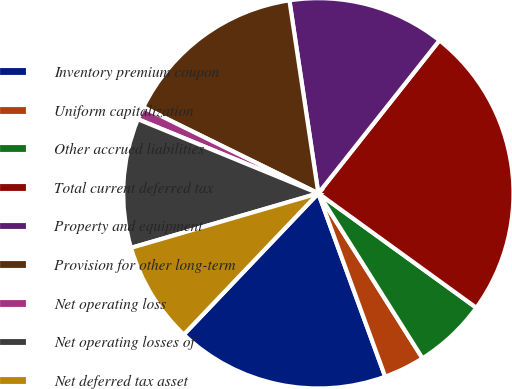Convert chart. <chart><loc_0><loc_0><loc_500><loc_500><pie_chart><fcel>Inventory premium coupon<fcel>Uniform capitalization<fcel>Other accrued liabilities<fcel>Total current deferred tax<fcel>Property and equipment<fcel>Provision for other long-term<fcel>Net operating loss<fcel>Net operating losses of<fcel>Net deferred tax asset<nl><fcel>17.68%<fcel>3.4%<fcel>6.06%<fcel>24.32%<fcel>13.03%<fcel>15.36%<fcel>1.07%<fcel>10.71%<fcel>8.38%<nl></chart> 